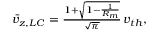<formula> <loc_0><loc_0><loc_500><loc_500>\begin{array} { r } { \bar { v } _ { z , L C } = \frac { 1 + \sqrt { 1 - \frac { 1 } { R _ { m } } } } { \sqrt { \pi } } \, v _ { t h } , } \end{array}</formula> 